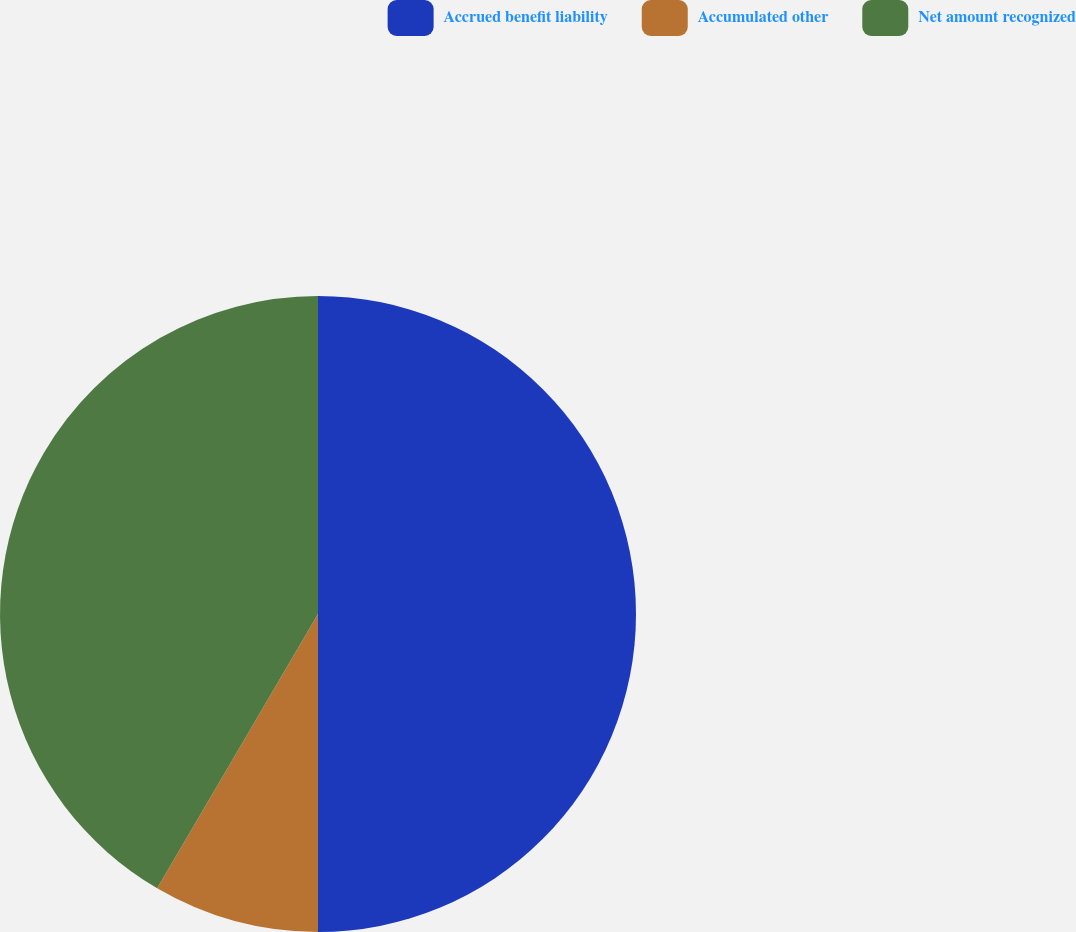Convert chart to OTSL. <chart><loc_0><loc_0><loc_500><loc_500><pie_chart><fcel>Accrued benefit liability<fcel>Accumulated other<fcel>Net amount recognized<nl><fcel>50.0%<fcel>8.44%<fcel>41.56%<nl></chart> 